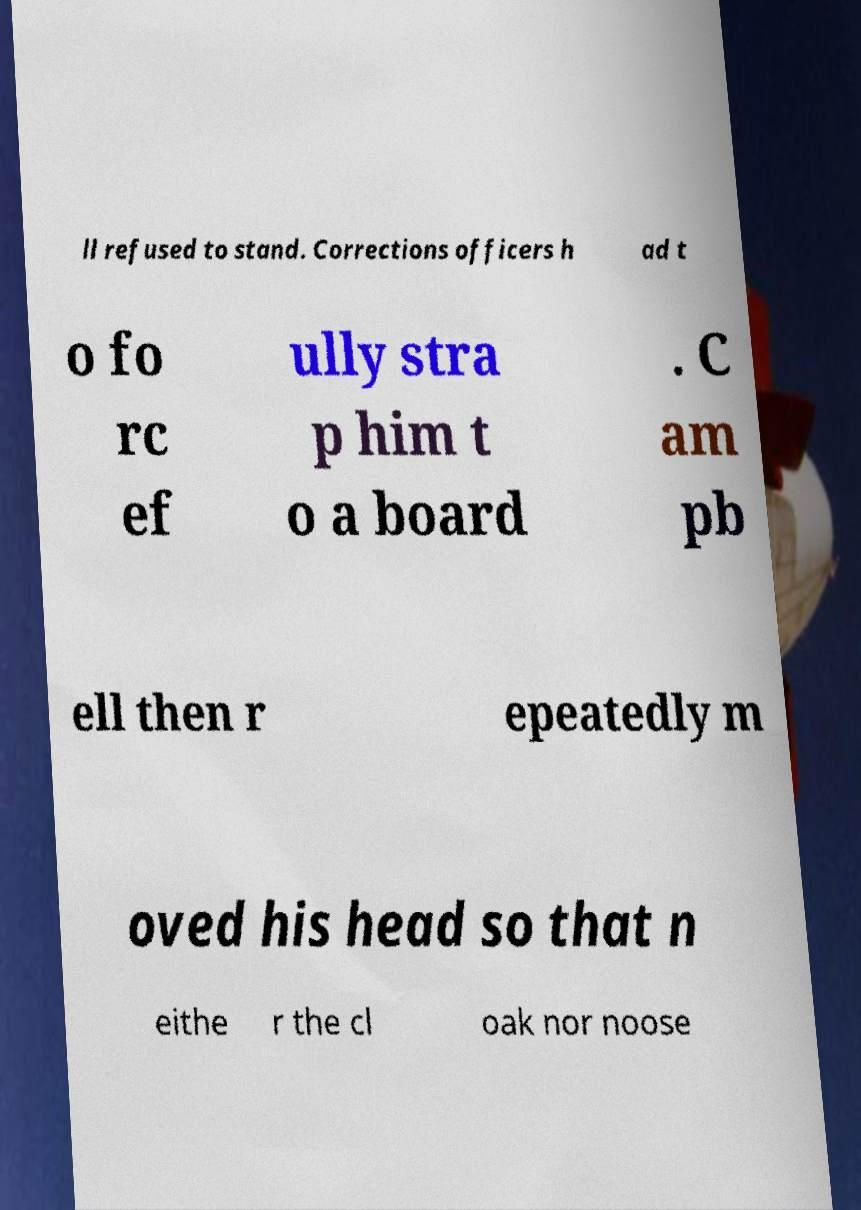Can you accurately transcribe the text from the provided image for me? ll refused to stand. Corrections officers h ad t o fo rc ef ully stra p him t o a board . C am pb ell then r epeatedly m oved his head so that n eithe r the cl oak nor noose 